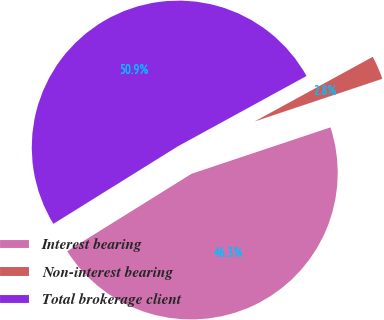<chart> <loc_0><loc_0><loc_500><loc_500><pie_chart><fcel>Interest bearing<fcel>Non-interest bearing<fcel>Total brokerage client<nl><fcel>46.27%<fcel>2.83%<fcel>50.9%<nl></chart> 